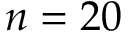Convert formula to latex. <formula><loc_0><loc_0><loc_500><loc_500>n = 2 0</formula> 